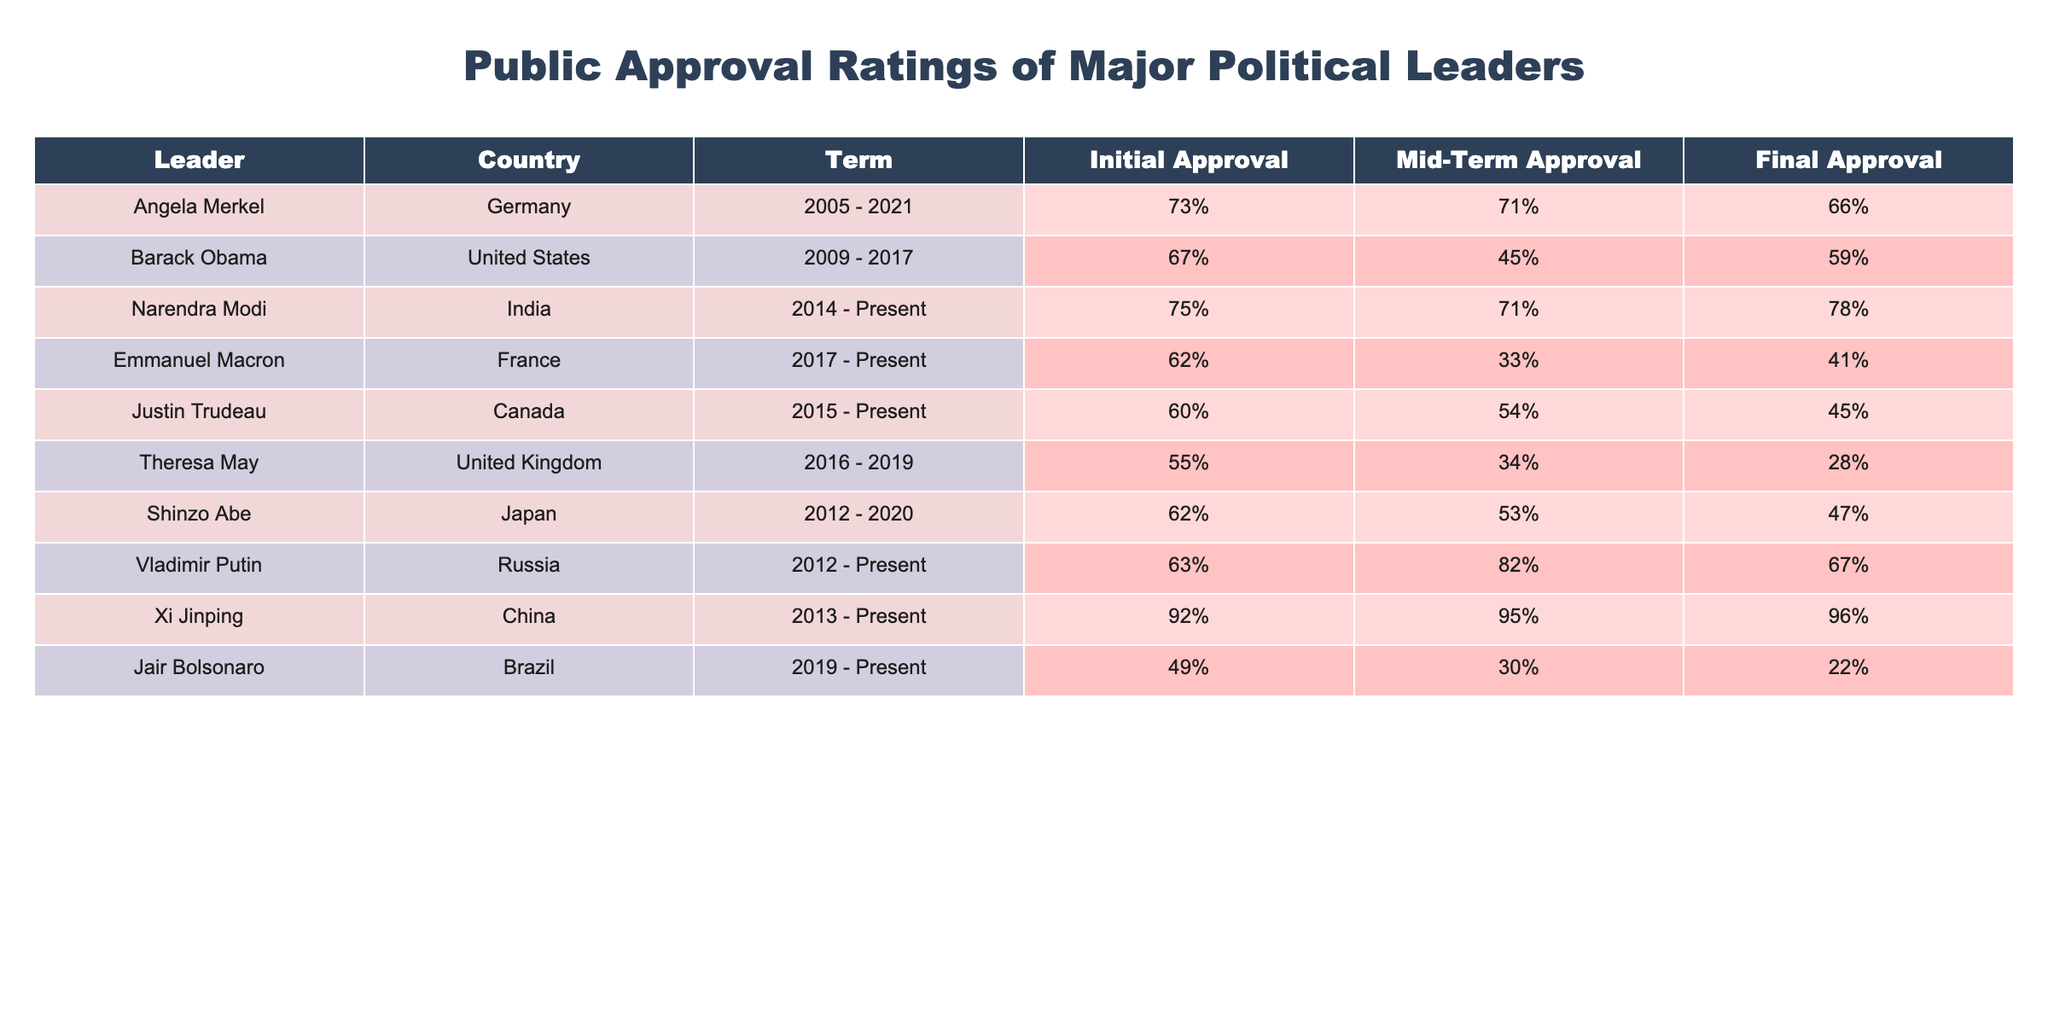What was the initial approval rating of Narendra Modi? The table shows Narendra Modi's initial approval rating listed under the 'Initial Approval' column, which is 75%.
Answer: 75% Which leader had the lowest final approval rating? By reviewing the 'Final Approval' column, Jair Bolsonaro has the lowest rating at 22%.
Answer: 22% How much did Angela Merkel's approval rating decline from the start to the end of her term? Angela Merkel's initial approval was 73% and her final approval was 66%. The decline can be calculated as 73% - 66% = 7%.
Answer: 7% Did Emmanual Macron's mid-term approval rating exceed his final approval rating? The mid-term approval for Emmanuel Macron is 33% and the final approval is 41%. Since 33% is less than 41%, the answer is no.
Answer: No Which leader experienced the largest drop in approval ratings from mid-term to final? We need to look at the mid-term and final approval ratings for all leaders. Emmanuel Macron has a mid-term approval of 33% and a final approval of 41%, experiencing a gain of 8%. Conversely, Theresa May declined from 34% to 28%, a drop of 6%. The largest drop is seen in Jair Bolsonaro, from 30% to 22%, which is an 8% drop.
Answer: Jair Bolsonaro 8% What is the average initial approval rating of the leaders in the table? By summing the initial approval ratings: (73 + 67 + 75 + 62 + 60 + 55 + 62 + 63 + 92 + 49) = 703. There are 10 leaders, thus the average is 703/10 = 70.3%.
Answer: 70.3% Is it true that Xi Jinping's final approval rating was higher than that of Vladimir Putin? Xi Jinping's final approval is 96% and Vladimir Putin's is 67%. Since 96% is greater than 67%, the answer is yes.
Answer: Yes Who had a higher mid-term approval rating, Barack Obama or Shinzo Abe? Barack Obama had a mid-term approval of 45% and Shinzo Abe had a mid-term approval of 53%. Comparing these numbers indicates that Shinzo Abe had the higher rating.
Answer: Shinzo Abe What is the difference between the initial approval ratings of Angela Merkel and Justin Trudeau? Angela Merkel's initial approval is 73% and Justin Trudeau's is 60%. The difference can be calculated by subtracting: 73% - 60% = 13%.
Answer: 13% 